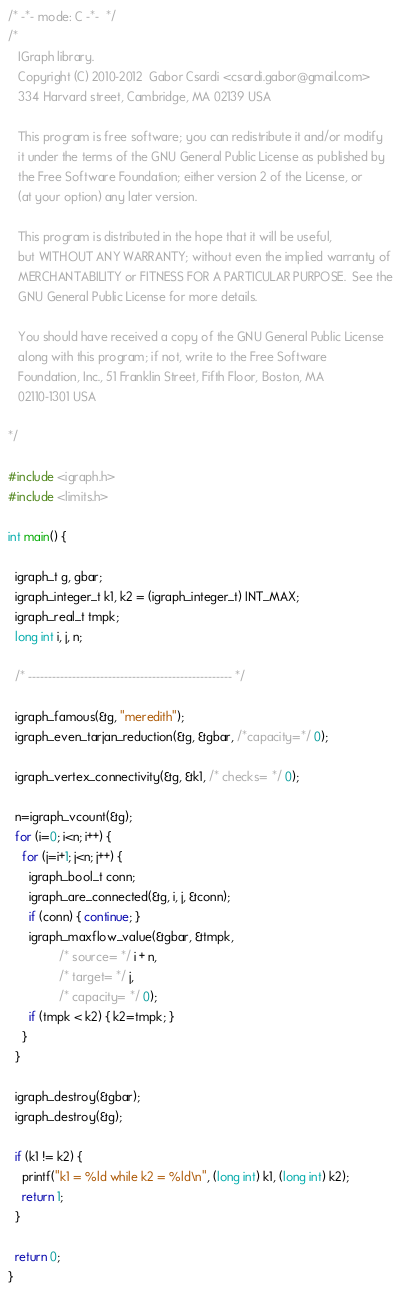Convert code to text. <code><loc_0><loc_0><loc_500><loc_500><_C_>/* -*- mode: C -*-  */
/* 
   IGraph library.
   Copyright (C) 2010-2012  Gabor Csardi <csardi.gabor@gmail.com>
   334 Harvard street, Cambridge, MA 02139 USA
   
   This program is free software; you can redistribute it and/or modify
   it under the terms of the GNU General Public License as published by
   the Free Software Foundation; either version 2 of the License, or
   (at your option) any later version.
   
   This program is distributed in the hope that it will be useful,
   but WITHOUT ANY WARRANTY; without even the implied warranty of
   MERCHANTABILITY or FITNESS FOR A PARTICULAR PURPOSE.  See the
   GNU General Public License for more details.
   
   You should have received a copy of the GNU General Public License
   along with this program; if not, write to the Free Software
   Foundation, Inc., 51 Franklin Street, Fifth Floor, Boston, MA 
   02110-1301 USA

*/

#include <igraph.h>
#include <limits.h>

int main() {

  igraph_t g, gbar;
  igraph_integer_t k1, k2 = (igraph_integer_t) INT_MAX;
  igraph_real_t tmpk;
  long int i, j, n;

  /* --------------------------------------------------- */
  
  igraph_famous(&g, "meredith");
  igraph_even_tarjan_reduction(&g, &gbar, /*capacity=*/ 0);
  
  igraph_vertex_connectivity(&g, &k1, /* checks= */ 0);

  n=igraph_vcount(&g);
  for (i=0; i<n; i++) {
    for (j=i+1; j<n; j++) {
      igraph_bool_t conn;
      igraph_are_connected(&g, i, j, &conn);
      if (conn) { continue; }
      igraph_maxflow_value(&gbar, &tmpk, 
			   /* source= */ i + n, 
			   /* target= */ j, 
			   /* capacity= */ 0);
      if (tmpk < k2) { k2=tmpk; }
    }
  }

  igraph_destroy(&gbar);
  igraph_destroy(&g);
  
  if (k1 != k2) {
    printf("k1 = %ld while k2 = %ld\n", (long int) k1, (long int) k2);
    return 1;
  }

  return 0;
}
</code> 